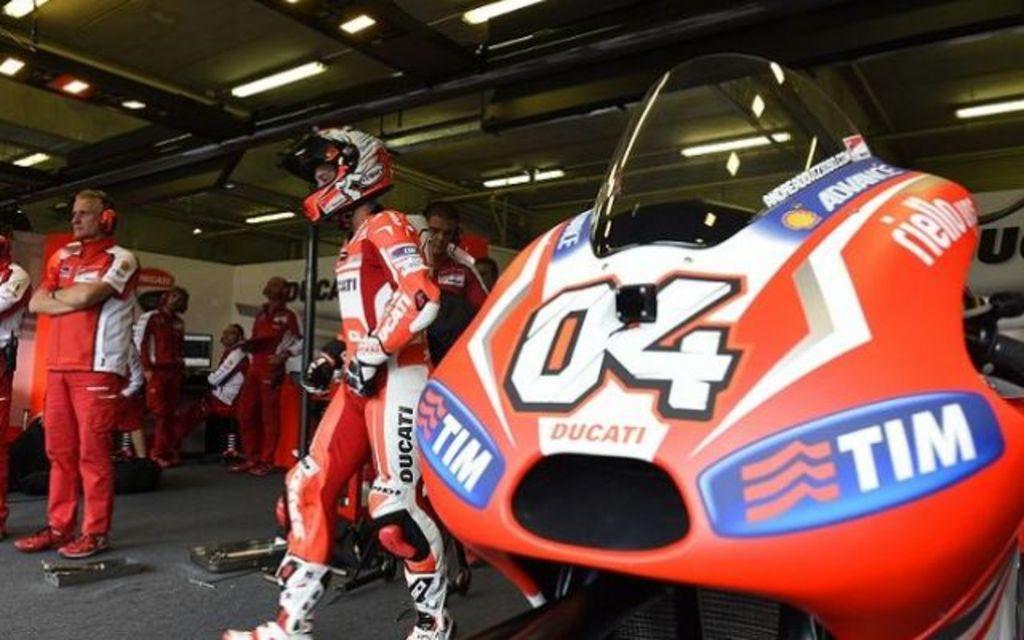How would you summarize this image in a sentence or two? In the center of the image there are persons walking on the floor. On the right side we can see a bike. On the left side there are persons standing on the floor. In the background there is a wall, monitor, lights and ceiling. 